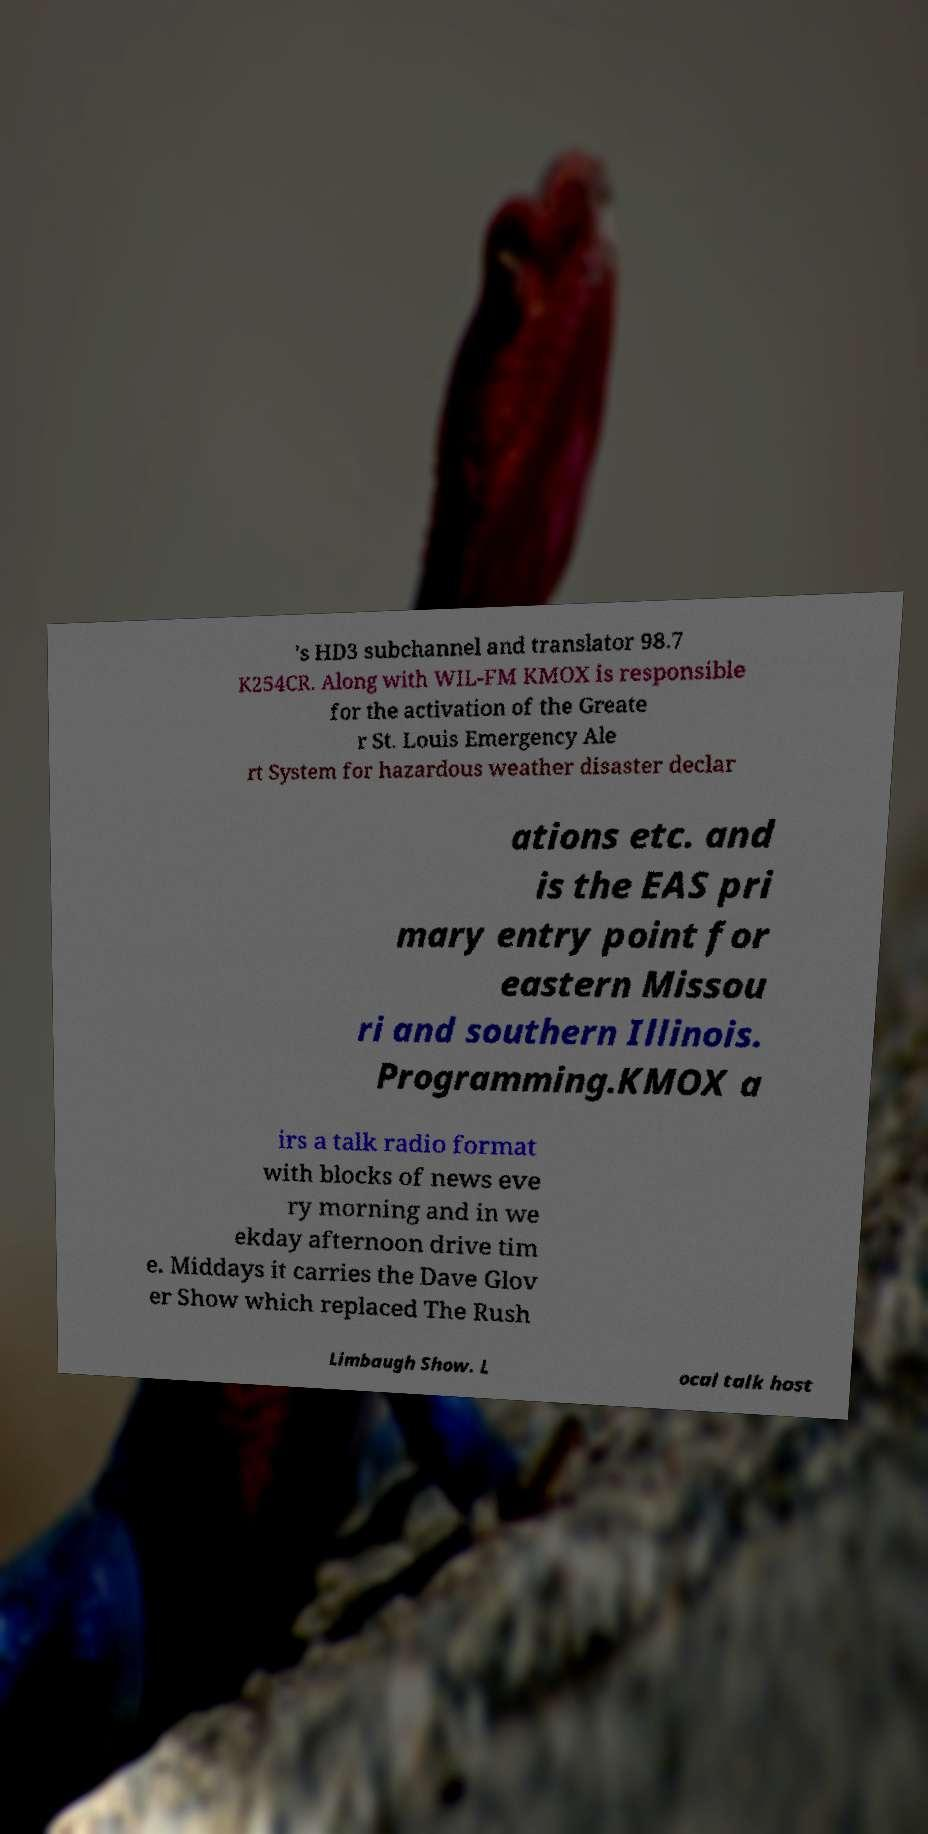What messages or text are displayed in this image? I need them in a readable, typed format. 's HD3 subchannel and translator 98.7 K254CR. Along with WIL-FM KMOX is responsible for the activation of the Greate r St. Louis Emergency Ale rt System for hazardous weather disaster declar ations etc. and is the EAS pri mary entry point for eastern Missou ri and southern Illinois. Programming.KMOX a irs a talk radio format with blocks of news eve ry morning and in we ekday afternoon drive tim e. Middays it carries the Dave Glov er Show which replaced The Rush Limbaugh Show. L ocal talk host 